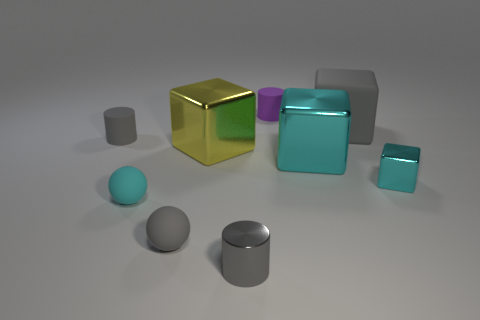What shapes are present in the image and how are they positioned in relation to each other? The image showcases an assortment of geometric shapes including cylinders, cubes, and spheres. The shapes are arranged in an almost haphazard manner but with enough space between them to distinguish each one. A large, reflective gold cube is central and somewhat front and center, with other shapes like the matte rubber cylinders and cubes positioned to its sides. A large gray cylinder lies in the background, giving it a sense of depth, while the spheres are scattered around the foreground, suggesting randomness in their placement. 